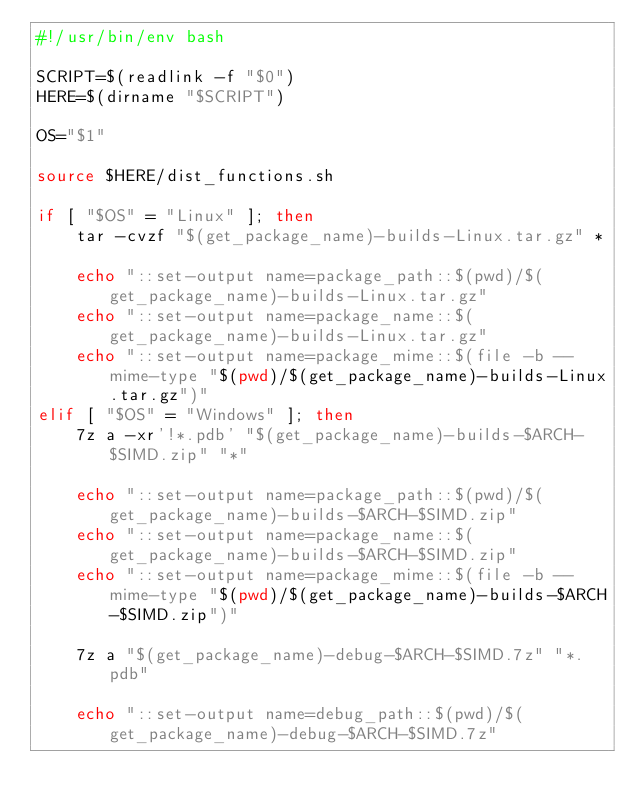<code> <loc_0><loc_0><loc_500><loc_500><_Bash_>#!/usr/bin/env bash

SCRIPT=$(readlink -f "$0")
HERE=$(dirname "$SCRIPT")

OS="$1"

source $HERE/dist_functions.sh

if [ "$OS" = "Linux" ]; then
    tar -cvzf "$(get_package_name)-builds-Linux.tar.gz" *

    echo "::set-output name=package_path::$(pwd)/$(get_package_name)-builds-Linux.tar.gz"
    echo "::set-output name=package_name::$(get_package_name)-builds-Linux.tar.gz"
    echo "::set-output name=package_mime::$(file -b --mime-type "$(pwd)/$(get_package_name)-builds-Linux.tar.gz")"
elif [ "$OS" = "Windows" ]; then
    7z a -xr'!*.pdb' "$(get_package_name)-builds-$ARCH-$SIMD.zip" "*"

    echo "::set-output name=package_path::$(pwd)/$(get_package_name)-builds-$ARCH-$SIMD.zip"
    echo "::set-output name=package_name::$(get_package_name)-builds-$ARCH-$SIMD.zip"
    echo "::set-output name=package_mime::$(file -b --mime-type "$(pwd)/$(get_package_name)-builds-$ARCH-$SIMD.zip")"

    7z a "$(get_package_name)-debug-$ARCH-$SIMD.7z" "*.pdb"

    echo "::set-output name=debug_path::$(pwd)/$(get_package_name)-debug-$ARCH-$SIMD.7z"</code> 